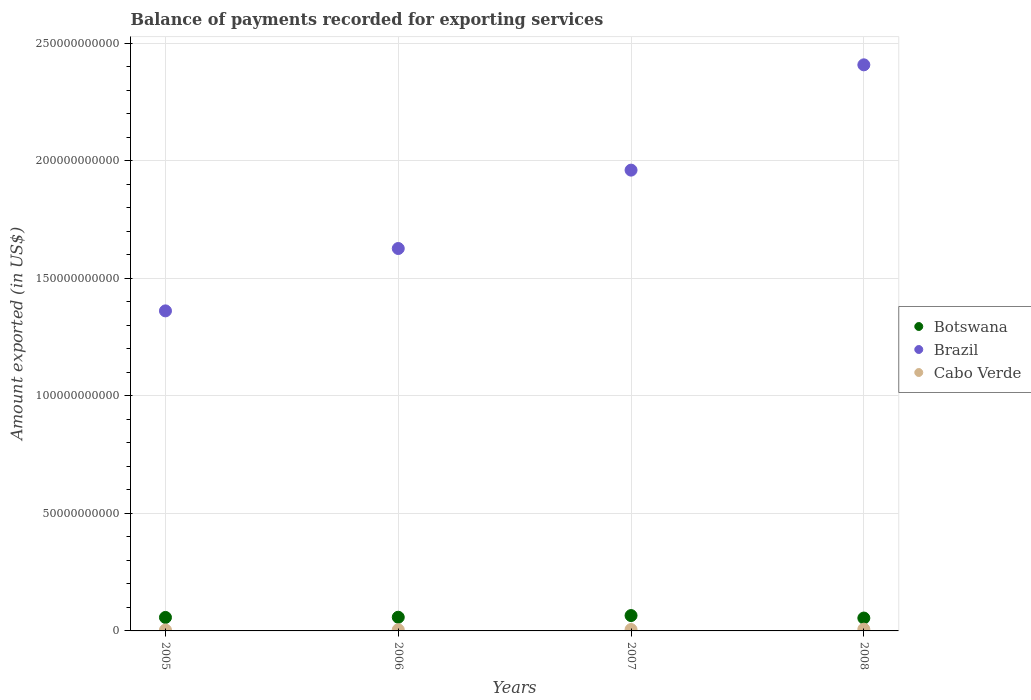Is the number of dotlines equal to the number of legend labels?
Offer a terse response. Yes. What is the amount exported in Botswana in 2005?
Ensure brevity in your answer.  5.74e+09. Across all years, what is the maximum amount exported in Brazil?
Keep it short and to the point. 2.41e+11. Across all years, what is the minimum amount exported in Brazil?
Provide a short and direct response. 1.36e+11. In which year was the amount exported in Cabo Verde maximum?
Provide a succinct answer. 2008. What is the total amount exported in Brazil in the graph?
Ensure brevity in your answer.  7.36e+11. What is the difference between the amount exported in Cabo Verde in 2006 and that in 2008?
Give a very brief answer. -2.47e+08. What is the difference between the amount exported in Cabo Verde in 2006 and the amount exported in Botswana in 2007?
Offer a terse response. -6.04e+09. What is the average amount exported in Cabo Verde per year?
Your answer should be very brief. 5.49e+08. In the year 2006, what is the difference between the amount exported in Brazil and amount exported in Cabo Verde?
Give a very brief answer. 1.62e+11. In how many years, is the amount exported in Cabo Verde greater than 170000000000 US$?
Provide a succinct answer. 0. What is the ratio of the amount exported in Brazil in 2006 to that in 2008?
Offer a very short reply. 0.68. What is the difference between the highest and the second highest amount exported in Cabo Verde?
Provide a succinct answer. 1.45e+08. What is the difference between the highest and the lowest amount exported in Botswana?
Provide a succinct answer. 1.06e+09. In how many years, is the amount exported in Brazil greater than the average amount exported in Brazil taken over all years?
Provide a short and direct response. 2. Is the sum of the amount exported in Brazil in 2006 and 2007 greater than the maximum amount exported in Cabo Verde across all years?
Give a very brief answer. Yes. Does the amount exported in Brazil monotonically increase over the years?
Your response must be concise. Yes. How many dotlines are there?
Make the answer very short. 3. What is the difference between two consecutive major ticks on the Y-axis?
Your answer should be very brief. 5.00e+1. Are the values on the major ticks of Y-axis written in scientific E-notation?
Offer a very short reply. No. Does the graph contain any zero values?
Offer a very short reply. No. Does the graph contain grids?
Your response must be concise. Yes. Where does the legend appear in the graph?
Your response must be concise. Center right. How many legend labels are there?
Offer a very short reply. 3. How are the legend labels stacked?
Provide a succinct answer. Vertical. What is the title of the graph?
Your answer should be compact. Balance of payments recorded for exporting services. What is the label or title of the Y-axis?
Make the answer very short. Amount exported (in US$). What is the Amount exported (in US$) of Botswana in 2005?
Give a very brief answer. 5.74e+09. What is the Amount exported (in US$) of Brazil in 2005?
Ensure brevity in your answer.  1.36e+11. What is the Amount exported (in US$) of Cabo Verde in 2005?
Offer a very short reply. 3.73e+08. What is the Amount exported (in US$) in Botswana in 2006?
Your answer should be very brief. 5.82e+09. What is the Amount exported (in US$) in Brazil in 2006?
Your answer should be compact. 1.63e+11. What is the Amount exported (in US$) in Cabo Verde in 2006?
Provide a succinct answer. 4.91e+08. What is the Amount exported (in US$) in Botswana in 2007?
Keep it short and to the point. 6.54e+09. What is the Amount exported (in US$) of Brazil in 2007?
Make the answer very short. 1.96e+11. What is the Amount exported (in US$) of Cabo Verde in 2007?
Offer a terse response. 5.93e+08. What is the Amount exported (in US$) in Botswana in 2008?
Keep it short and to the point. 5.47e+09. What is the Amount exported (in US$) of Brazil in 2008?
Your answer should be very brief. 2.41e+11. What is the Amount exported (in US$) of Cabo Verde in 2008?
Provide a succinct answer. 7.38e+08. Across all years, what is the maximum Amount exported (in US$) in Botswana?
Provide a succinct answer. 6.54e+09. Across all years, what is the maximum Amount exported (in US$) of Brazil?
Your answer should be compact. 2.41e+11. Across all years, what is the maximum Amount exported (in US$) of Cabo Verde?
Keep it short and to the point. 7.38e+08. Across all years, what is the minimum Amount exported (in US$) in Botswana?
Offer a terse response. 5.47e+09. Across all years, what is the minimum Amount exported (in US$) in Brazil?
Offer a very short reply. 1.36e+11. Across all years, what is the minimum Amount exported (in US$) in Cabo Verde?
Ensure brevity in your answer.  3.73e+08. What is the total Amount exported (in US$) in Botswana in the graph?
Offer a very short reply. 2.36e+1. What is the total Amount exported (in US$) in Brazil in the graph?
Ensure brevity in your answer.  7.36e+11. What is the total Amount exported (in US$) of Cabo Verde in the graph?
Your answer should be compact. 2.20e+09. What is the difference between the Amount exported (in US$) in Botswana in 2005 and that in 2006?
Offer a terse response. -8.08e+07. What is the difference between the Amount exported (in US$) in Brazil in 2005 and that in 2006?
Provide a short and direct response. -2.65e+1. What is the difference between the Amount exported (in US$) of Cabo Verde in 2005 and that in 2006?
Offer a terse response. -1.18e+08. What is the difference between the Amount exported (in US$) of Botswana in 2005 and that in 2007?
Provide a succinct answer. -7.97e+08. What is the difference between the Amount exported (in US$) of Brazil in 2005 and that in 2007?
Your response must be concise. -5.99e+1. What is the difference between the Amount exported (in US$) in Cabo Verde in 2005 and that in 2007?
Provide a short and direct response. -2.20e+08. What is the difference between the Amount exported (in US$) in Botswana in 2005 and that in 2008?
Make the answer very short. 2.65e+08. What is the difference between the Amount exported (in US$) in Brazil in 2005 and that in 2008?
Your response must be concise. -1.05e+11. What is the difference between the Amount exported (in US$) in Cabo Verde in 2005 and that in 2008?
Provide a short and direct response. -3.65e+08. What is the difference between the Amount exported (in US$) in Botswana in 2006 and that in 2007?
Give a very brief answer. -7.16e+08. What is the difference between the Amount exported (in US$) of Brazil in 2006 and that in 2007?
Offer a very short reply. -3.34e+1. What is the difference between the Amount exported (in US$) of Cabo Verde in 2006 and that in 2007?
Make the answer very short. -1.01e+08. What is the difference between the Amount exported (in US$) in Botswana in 2006 and that in 2008?
Your response must be concise. 3.46e+08. What is the difference between the Amount exported (in US$) of Brazil in 2006 and that in 2008?
Keep it short and to the point. -7.82e+1. What is the difference between the Amount exported (in US$) of Cabo Verde in 2006 and that in 2008?
Provide a short and direct response. -2.47e+08. What is the difference between the Amount exported (in US$) in Botswana in 2007 and that in 2008?
Offer a terse response. 1.06e+09. What is the difference between the Amount exported (in US$) of Brazil in 2007 and that in 2008?
Offer a very short reply. -4.48e+1. What is the difference between the Amount exported (in US$) of Cabo Verde in 2007 and that in 2008?
Ensure brevity in your answer.  -1.45e+08. What is the difference between the Amount exported (in US$) of Botswana in 2005 and the Amount exported (in US$) of Brazil in 2006?
Offer a terse response. -1.57e+11. What is the difference between the Amount exported (in US$) in Botswana in 2005 and the Amount exported (in US$) in Cabo Verde in 2006?
Offer a very short reply. 5.25e+09. What is the difference between the Amount exported (in US$) of Brazil in 2005 and the Amount exported (in US$) of Cabo Verde in 2006?
Offer a very short reply. 1.36e+11. What is the difference between the Amount exported (in US$) in Botswana in 2005 and the Amount exported (in US$) in Brazil in 2007?
Keep it short and to the point. -1.90e+11. What is the difference between the Amount exported (in US$) of Botswana in 2005 and the Amount exported (in US$) of Cabo Verde in 2007?
Make the answer very short. 5.15e+09. What is the difference between the Amount exported (in US$) in Brazil in 2005 and the Amount exported (in US$) in Cabo Verde in 2007?
Keep it short and to the point. 1.36e+11. What is the difference between the Amount exported (in US$) in Botswana in 2005 and the Amount exported (in US$) in Brazil in 2008?
Provide a succinct answer. -2.35e+11. What is the difference between the Amount exported (in US$) in Botswana in 2005 and the Amount exported (in US$) in Cabo Verde in 2008?
Your answer should be very brief. 5.00e+09. What is the difference between the Amount exported (in US$) of Brazil in 2005 and the Amount exported (in US$) of Cabo Verde in 2008?
Offer a terse response. 1.35e+11. What is the difference between the Amount exported (in US$) of Botswana in 2006 and the Amount exported (in US$) of Brazil in 2007?
Your answer should be compact. -1.90e+11. What is the difference between the Amount exported (in US$) in Botswana in 2006 and the Amount exported (in US$) in Cabo Verde in 2007?
Ensure brevity in your answer.  5.23e+09. What is the difference between the Amount exported (in US$) in Brazil in 2006 and the Amount exported (in US$) in Cabo Verde in 2007?
Your answer should be very brief. 1.62e+11. What is the difference between the Amount exported (in US$) in Botswana in 2006 and the Amount exported (in US$) in Brazil in 2008?
Ensure brevity in your answer.  -2.35e+11. What is the difference between the Amount exported (in US$) in Botswana in 2006 and the Amount exported (in US$) in Cabo Verde in 2008?
Make the answer very short. 5.08e+09. What is the difference between the Amount exported (in US$) in Brazil in 2006 and the Amount exported (in US$) in Cabo Verde in 2008?
Keep it short and to the point. 1.62e+11. What is the difference between the Amount exported (in US$) of Botswana in 2007 and the Amount exported (in US$) of Brazil in 2008?
Keep it short and to the point. -2.34e+11. What is the difference between the Amount exported (in US$) in Botswana in 2007 and the Amount exported (in US$) in Cabo Verde in 2008?
Offer a terse response. 5.80e+09. What is the difference between the Amount exported (in US$) of Brazil in 2007 and the Amount exported (in US$) of Cabo Verde in 2008?
Keep it short and to the point. 1.95e+11. What is the average Amount exported (in US$) in Botswana per year?
Provide a short and direct response. 5.89e+09. What is the average Amount exported (in US$) in Brazil per year?
Offer a terse response. 1.84e+11. What is the average Amount exported (in US$) in Cabo Verde per year?
Make the answer very short. 5.49e+08. In the year 2005, what is the difference between the Amount exported (in US$) of Botswana and Amount exported (in US$) of Brazil?
Give a very brief answer. -1.30e+11. In the year 2005, what is the difference between the Amount exported (in US$) in Botswana and Amount exported (in US$) in Cabo Verde?
Your response must be concise. 5.37e+09. In the year 2005, what is the difference between the Amount exported (in US$) in Brazil and Amount exported (in US$) in Cabo Verde?
Your response must be concise. 1.36e+11. In the year 2006, what is the difference between the Amount exported (in US$) in Botswana and Amount exported (in US$) in Brazil?
Ensure brevity in your answer.  -1.57e+11. In the year 2006, what is the difference between the Amount exported (in US$) in Botswana and Amount exported (in US$) in Cabo Verde?
Make the answer very short. 5.33e+09. In the year 2006, what is the difference between the Amount exported (in US$) of Brazil and Amount exported (in US$) of Cabo Verde?
Keep it short and to the point. 1.62e+11. In the year 2007, what is the difference between the Amount exported (in US$) of Botswana and Amount exported (in US$) of Brazil?
Provide a succinct answer. -1.90e+11. In the year 2007, what is the difference between the Amount exported (in US$) in Botswana and Amount exported (in US$) in Cabo Verde?
Make the answer very short. 5.94e+09. In the year 2007, what is the difference between the Amount exported (in US$) of Brazil and Amount exported (in US$) of Cabo Verde?
Provide a short and direct response. 1.96e+11. In the year 2008, what is the difference between the Amount exported (in US$) of Botswana and Amount exported (in US$) of Brazil?
Ensure brevity in your answer.  -2.35e+11. In the year 2008, what is the difference between the Amount exported (in US$) in Botswana and Amount exported (in US$) in Cabo Verde?
Make the answer very short. 4.74e+09. In the year 2008, what is the difference between the Amount exported (in US$) of Brazil and Amount exported (in US$) of Cabo Verde?
Give a very brief answer. 2.40e+11. What is the ratio of the Amount exported (in US$) in Botswana in 2005 to that in 2006?
Give a very brief answer. 0.99. What is the ratio of the Amount exported (in US$) in Brazil in 2005 to that in 2006?
Offer a terse response. 0.84. What is the ratio of the Amount exported (in US$) of Cabo Verde in 2005 to that in 2006?
Offer a very short reply. 0.76. What is the ratio of the Amount exported (in US$) of Botswana in 2005 to that in 2007?
Your answer should be very brief. 0.88. What is the ratio of the Amount exported (in US$) in Brazil in 2005 to that in 2007?
Your response must be concise. 0.69. What is the ratio of the Amount exported (in US$) of Cabo Verde in 2005 to that in 2007?
Provide a short and direct response. 0.63. What is the ratio of the Amount exported (in US$) in Botswana in 2005 to that in 2008?
Ensure brevity in your answer.  1.05. What is the ratio of the Amount exported (in US$) of Brazil in 2005 to that in 2008?
Make the answer very short. 0.57. What is the ratio of the Amount exported (in US$) of Cabo Verde in 2005 to that in 2008?
Keep it short and to the point. 0.51. What is the ratio of the Amount exported (in US$) in Botswana in 2006 to that in 2007?
Keep it short and to the point. 0.89. What is the ratio of the Amount exported (in US$) of Brazil in 2006 to that in 2007?
Give a very brief answer. 0.83. What is the ratio of the Amount exported (in US$) of Cabo Verde in 2006 to that in 2007?
Give a very brief answer. 0.83. What is the ratio of the Amount exported (in US$) in Botswana in 2006 to that in 2008?
Ensure brevity in your answer.  1.06. What is the ratio of the Amount exported (in US$) in Brazil in 2006 to that in 2008?
Keep it short and to the point. 0.68. What is the ratio of the Amount exported (in US$) in Cabo Verde in 2006 to that in 2008?
Make the answer very short. 0.67. What is the ratio of the Amount exported (in US$) in Botswana in 2007 to that in 2008?
Give a very brief answer. 1.19. What is the ratio of the Amount exported (in US$) of Brazil in 2007 to that in 2008?
Your response must be concise. 0.81. What is the ratio of the Amount exported (in US$) of Cabo Verde in 2007 to that in 2008?
Your answer should be compact. 0.8. What is the difference between the highest and the second highest Amount exported (in US$) of Botswana?
Offer a very short reply. 7.16e+08. What is the difference between the highest and the second highest Amount exported (in US$) in Brazil?
Offer a terse response. 4.48e+1. What is the difference between the highest and the second highest Amount exported (in US$) in Cabo Verde?
Provide a short and direct response. 1.45e+08. What is the difference between the highest and the lowest Amount exported (in US$) in Botswana?
Your response must be concise. 1.06e+09. What is the difference between the highest and the lowest Amount exported (in US$) in Brazil?
Your answer should be compact. 1.05e+11. What is the difference between the highest and the lowest Amount exported (in US$) in Cabo Verde?
Your answer should be very brief. 3.65e+08. 